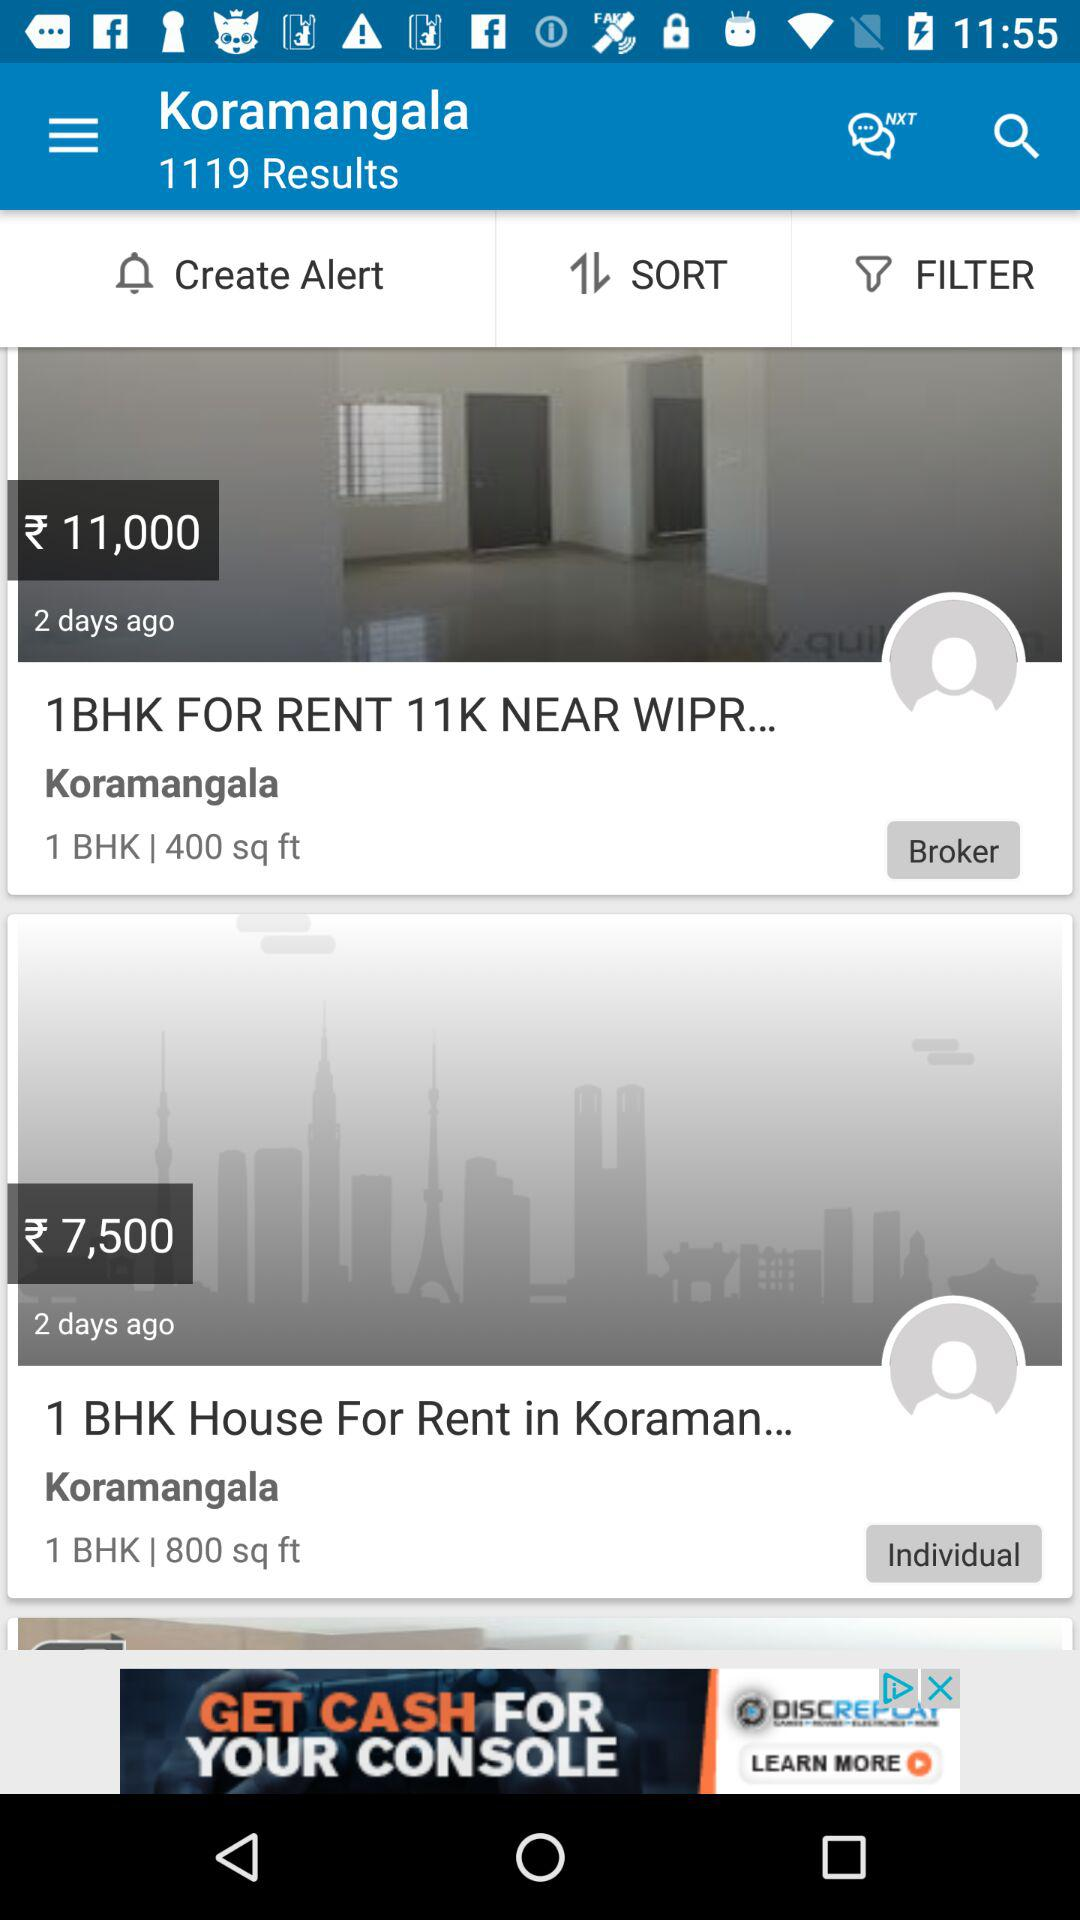What is the number of results? The number of results is 1119. 